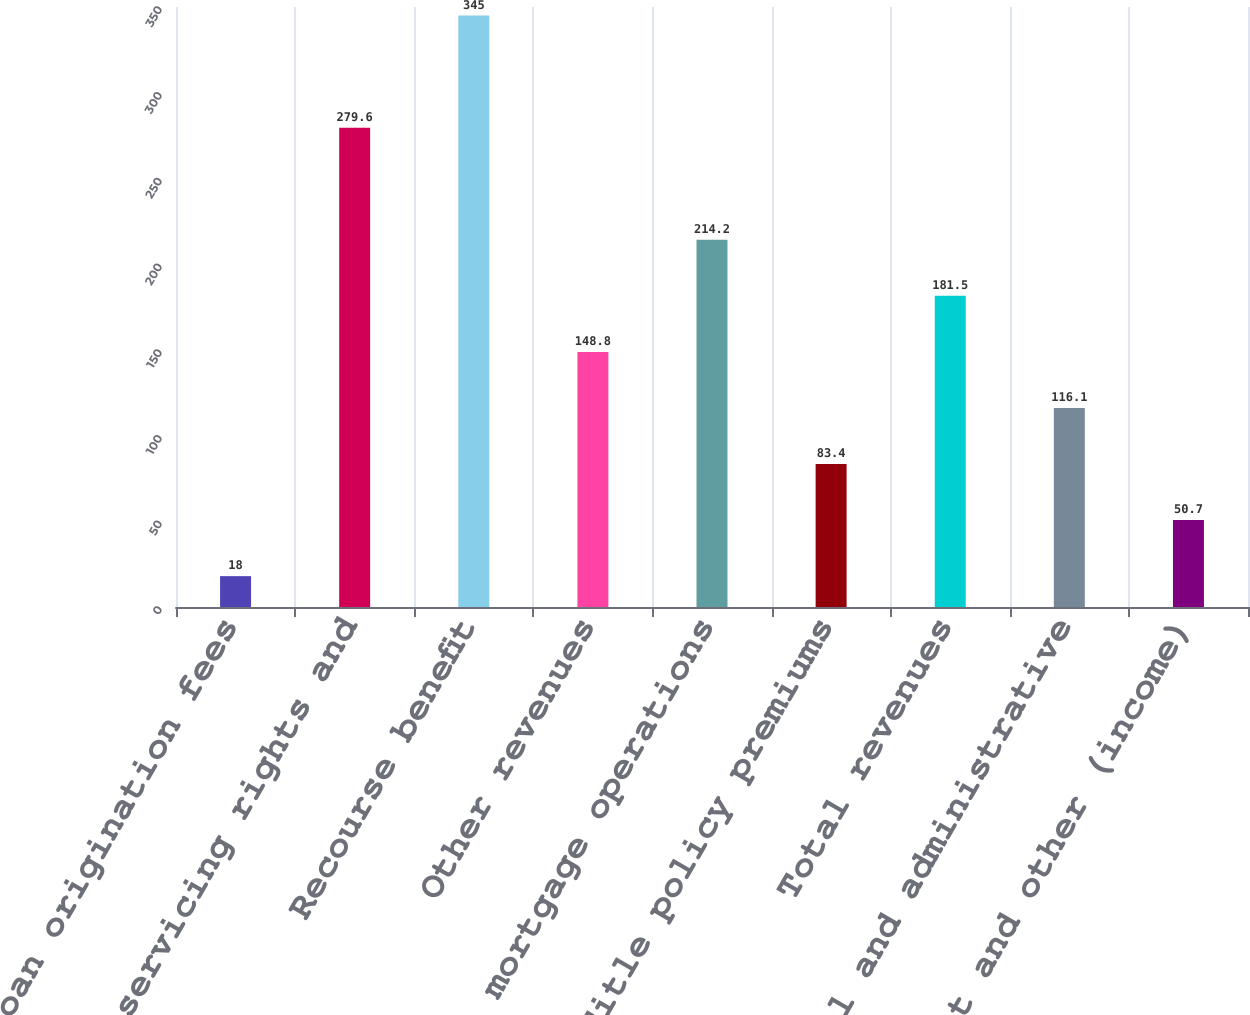<chart> <loc_0><loc_0><loc_500><loc_500><bar_chart><fcel>Loan origination fees<fcel>Sale of servicing rights and<fcel>Recourse benefit<fcel>Other revenues<fcel>Total mortgage operations<fcel>Title policy premiums<fcel>Total revenues<fcel>General and administrative<fcel>Interest and other (income)<nl><fcel>18<fcel>279.6<fcel>345<fcel>148.8<fcel>214.2<fcel>83.4<fcel>181.5<fcel>116.1<fcel>50.7<nl></chart> 